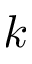<formula> <loc_0><loc_0><loc_500><loc_500>k</formula> 